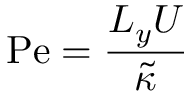<formula> <loc_0><loc_0><loc_500><loc_500>P e = \frac { L _ { y } U } { \tilde { \kappa } }</formula> 